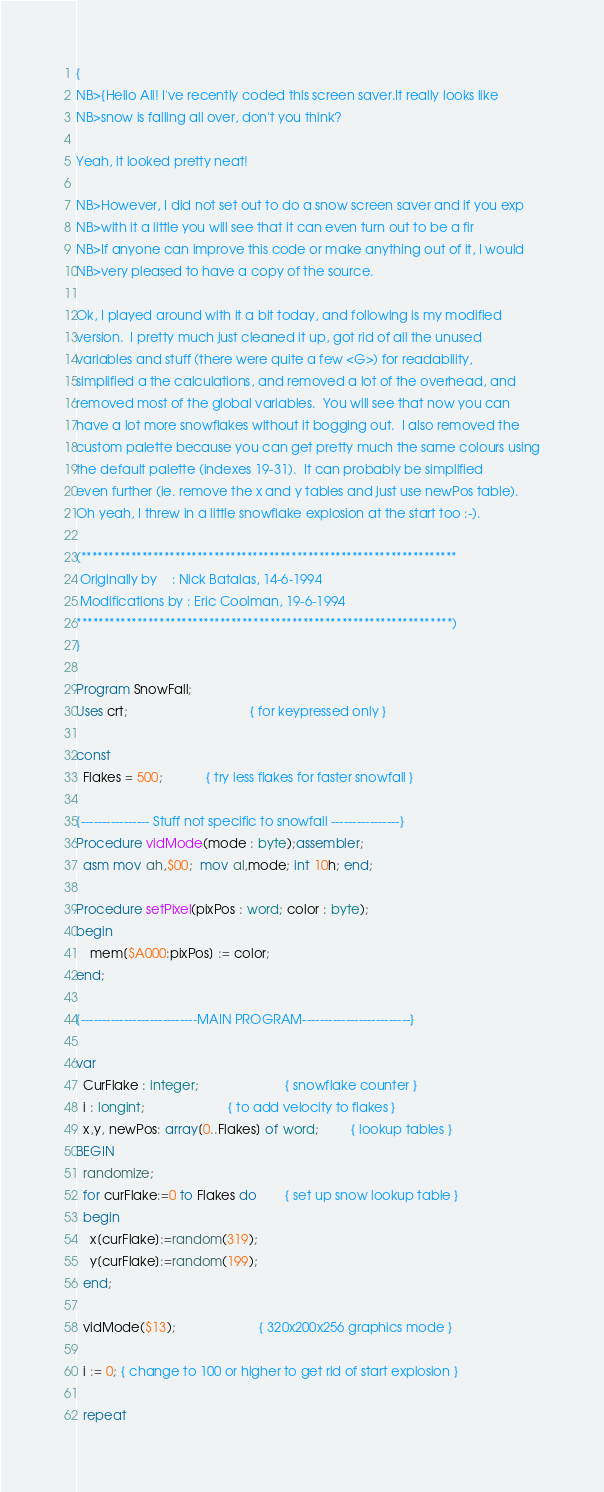<code> <loc_0><loc_0><loc_500><loc_500><_Pascal_>{
NB>{Hello All! I've recently coded this screen saver.It really looks like
NB>snow is falling all over, don't you think?

Yeah, it looked pretty neat!

NB>However, I did not set out to do a snow screen saver and if you exp
NB>with it a little you will see that it can even turn out to be a fir
NB>If anyone can improve this code or make anything out of it, I would
NB>very pleased to have a copy of the source.

Ok, I played around with it a bit today, and following is my modified
version.  I pretty much just cleaned it up, got rid of all the unused
variables and stuff (there were quite a few <G>) for readability,
simplified a the calculations, and removed a lot of the overhead, and
removed most of the global variables.  You will see that now you can
have a lot more snowflakes without it bogging out.  I also removed the
custom palette because you can get pretty much the same colours using
the default palette (indexes 19-31).  It can probably be simplified
even further (ie. remove the x and y tables and just use newPos table).
Oh yeah, I threw in a little snowflake explosion at the start too :-).

(********************************************************************
 Originally by    : Nick Batalas, 14-6-1994
 Modifications by : Eric Coolman, 19-6-1994
********************************************************************)
}

Program SnowFall;
Uses crt;                                  { for keypressed only }

const
  Flakes = 500;            { try less flakes for faster snowfall }

{---------------- Stuff not specific to snowfall ----------------}
Procedure vidMode(mode : byte);assembler;
  asm mov ah,$00;  mov al,mode; int 10h; end;

Procedure setPixel(pixPos : word; color : byte);
begin
    mem[$A000:pixPos] := color;
end;

{---------------------------MAIN PROGRAM-------------------------}

var
  CurFlake : integer;                        { snowflake counter }
  i : longint;                       { to add velocity to flakes }
  x,y, newPos: array[0..Flakes] of word;         { lookup tables }
BEGIN
  randomize;
  for curFlake:=0 to Flakes do        { set up snow lookup table }
  begin
    x[curFlake]:=random(319);
    y[curFlake]:=random(199);
  end;

  vidMode($13);                       { 320x200x256 graphics mode }

  i := 0; { change to 100 or higher to get rid of start explosion }

  repeat</code> 